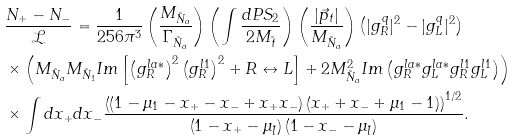<formula> <loc_0><loc_0><loc_500><loc_500>& \frac { N _ { + } - N _ { - } } { \mathcal { L } } = \frac { 1 } { 2 5 6 \pi ^ { 3 } } \left ( \frac { M _ { \tilde { N } _ { a } } } { \Gamma _ { \tilde { N } _ { a } } } \right ) \left ( \int \frac { d P S _ { 2 } } { 2 M _ { \tilde { t } } } \right ) \left ( \frac { | \vec { p } _ { t } | } { M _ { \tilde { N } _ { a } } } \right ) \left ( | g _ { R } ^ { q } | ^ { 2 } - | g _ { L } ^ { q } | ^ { 2 } \right ) \\ & \times \left ( M _ { \tilde { N } _ { a } } M _ { \tilde { N } _ { 1 } } I m \left [ \left ( g _ { R } ^ { l a * } \right ) ^ { 2 } \left ( g _ { R } ^ { l 1 } \right ) ^ { 2 } + R \leftrightarrow L \right ] + 2 M _ { \tilde { N } _ { a } } ^ { 2 } I m \left ( g _ { R } ^ { l a * } g _ { L } ^ { l a * } g _ { R } ^ { l 1 } g _ { L } ^ { l 1 } \right ) \right ) \\ & \times \int d x _ { + } d x _ { - } \frac { \left ( \left ( 1 - \mu _ { 1 } - x _ { + } - x _ { - } + x _ { + } x _ { - } \right ) \left ( x _ { + } + x _ { - } + \mu _ { 1 } - 1 \right ) \right ) ^ { 1 / 2 } } { \left ( 1 - x _ { + } - \mu _ { \tilde { l } } \right ) \left ( 1 - x _ { - } - \mu _ { \tilde { l } } \right ) } .</formula> 